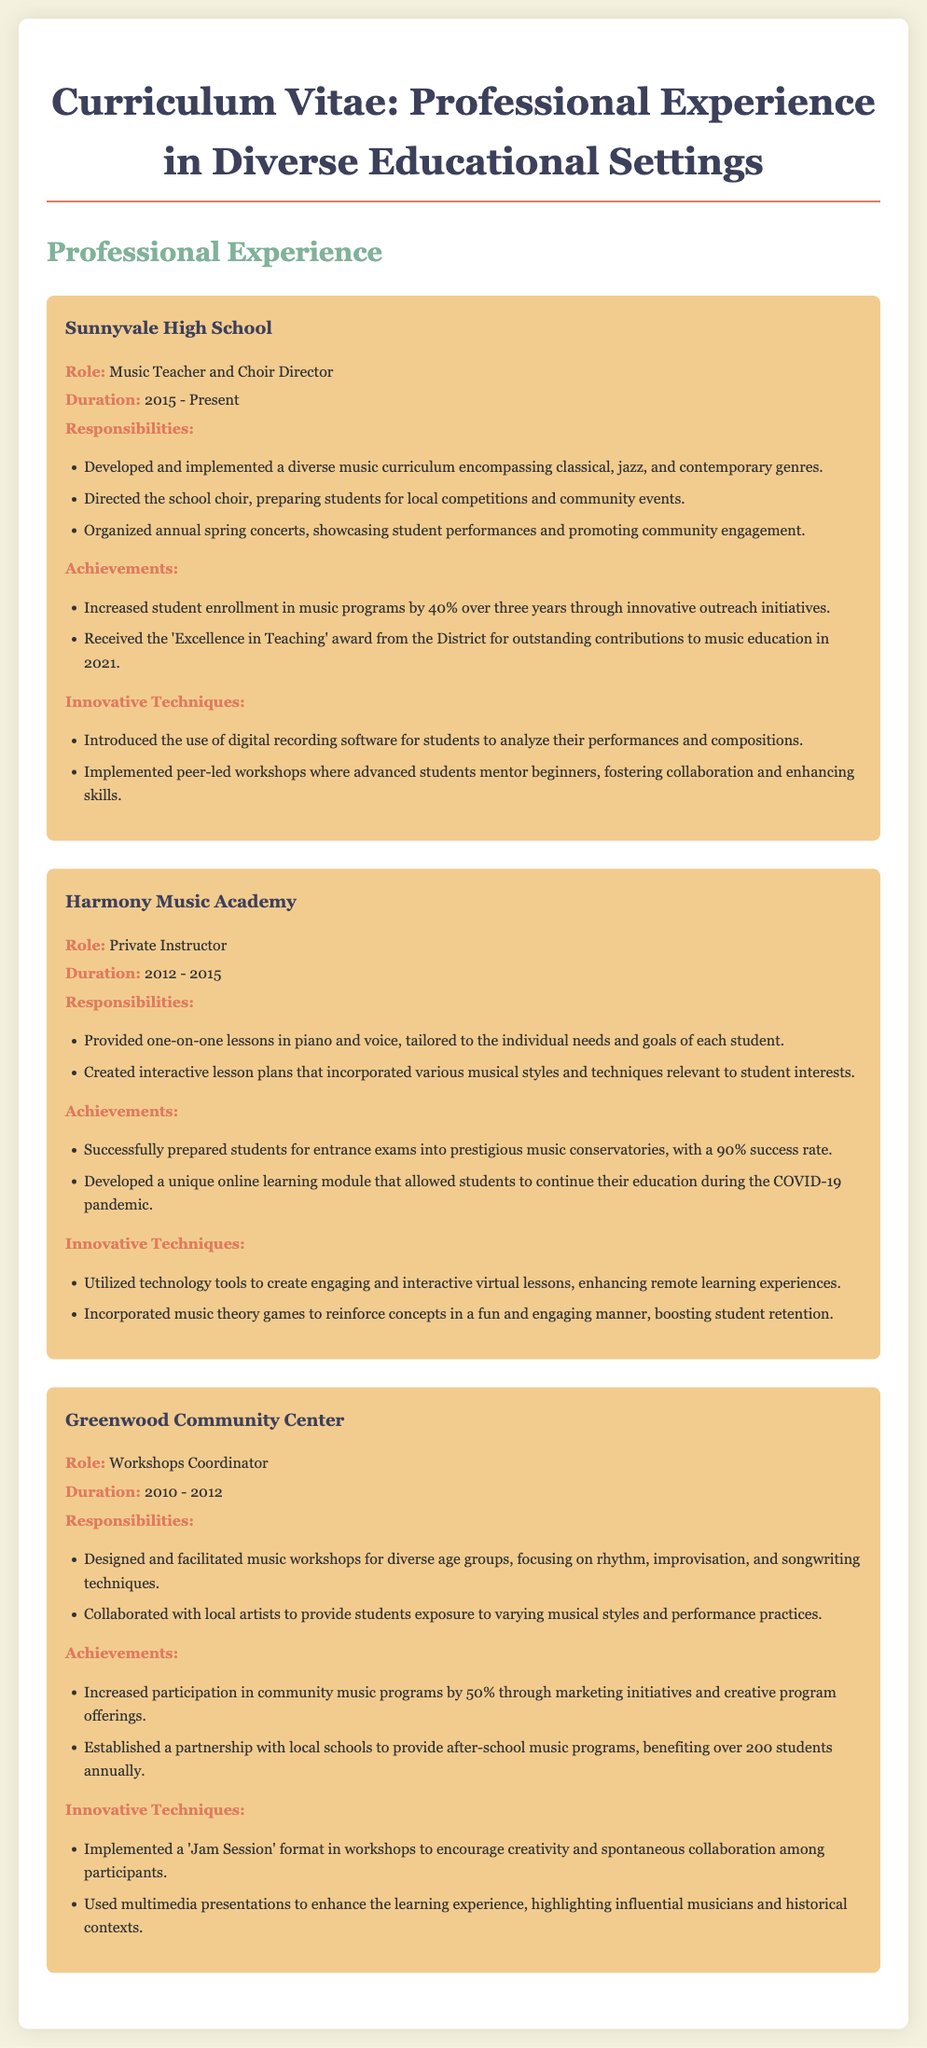What is the role of the teacher at Sunnyvale High School? The document states the teacher's role at Sunnyvale High School as "Music Teacher and Choir Director."
Answer: Music Teacher and Choir Director What is the duration of the teaching role at Harmony Music Academy? The duration of the role at Harmony Music Academy is provided as "2012 - 2015."
Answer: 2012 - 2015 What innovative technique was introduced at Sunnyvale High School? The document mentions the introduction of "digital recording software for students to analyze their performances and compositions."
Answer: digital recording software How much did student enrollment increase at Sunnyvale High School? The document indicates that there was a "40% increase" in student enrollment in music programs.
Answer: 40% What achievement is highlighted in the Professional Experience section? The document highlights the achievement of receiving the "Excellence in Teaching" award in 2021.
Answer: Excellence in Teaching award Which community was served by the Greenwood Community Center's music programs? The document states that the Greenwood Community Center's programs involved "over 200 students annually" from local schools.
Answer: over 200 students annually What unique online module did the teacher develop during COVID-19? The document mentions the development of "a unique online learning module."
Answer: a unique online learning module What was the focus of the workshops designed at the Greenwood Community Center? The workshops focused on "rhythm, improvisation, and songwriting techniques."
Answer: rhythm, improvisation, and songwriting techniques 